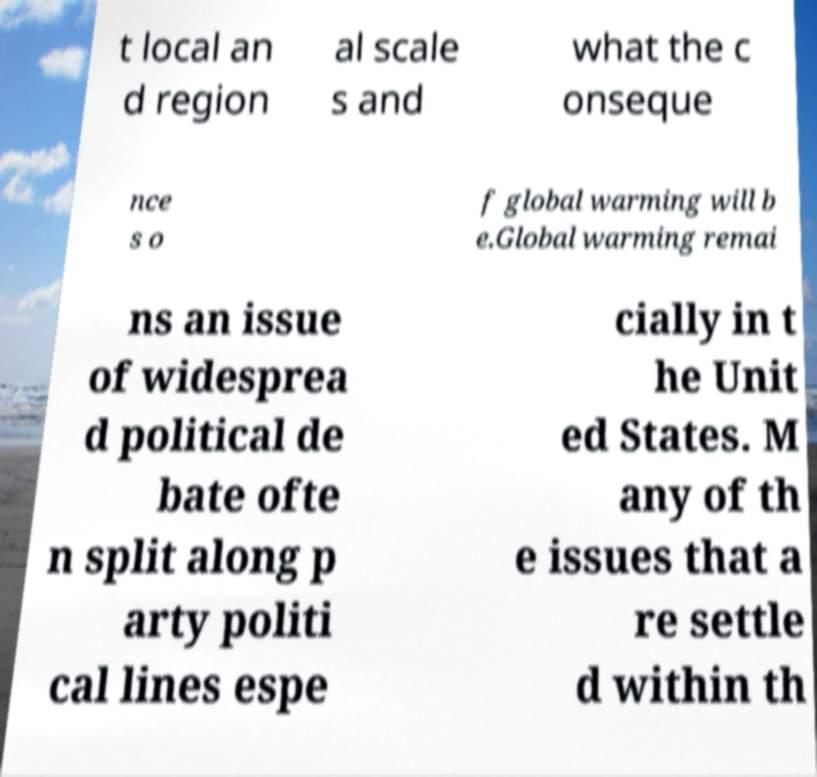For documentation purposes, I need the text within this image transcribed. Could you provide that? t local an d region al scale s and what the c onseque nce s o f global warming will b e.Global warming remai ns an issue of widesprea d political de bate ofte n split along p arty politi cal lines espe cially in t he Unit ed States. M any of th e issues that a re settle d within th 